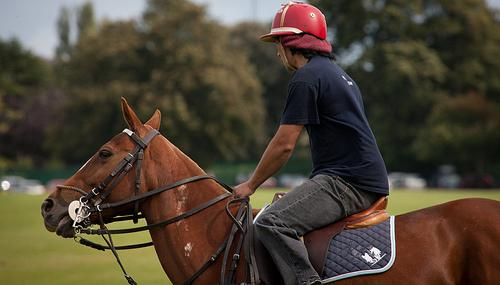Question: what color are the blades of grass?
Choices:
A. Green.
B. Yellow.
C. Brown.
D. White.
Answer with the letter. Answer: A Question: what color helmet is the rider wearing?
Choices:
A. Blue.
B. Green.
C. Black.
D. Red.
Answer with the letter. Answer: D Question: what color trees are in the background?
Choices:
A. Yellow.
B. Orange.
C. Green.
D. Brown.
Answer with the letter. Answer: C 